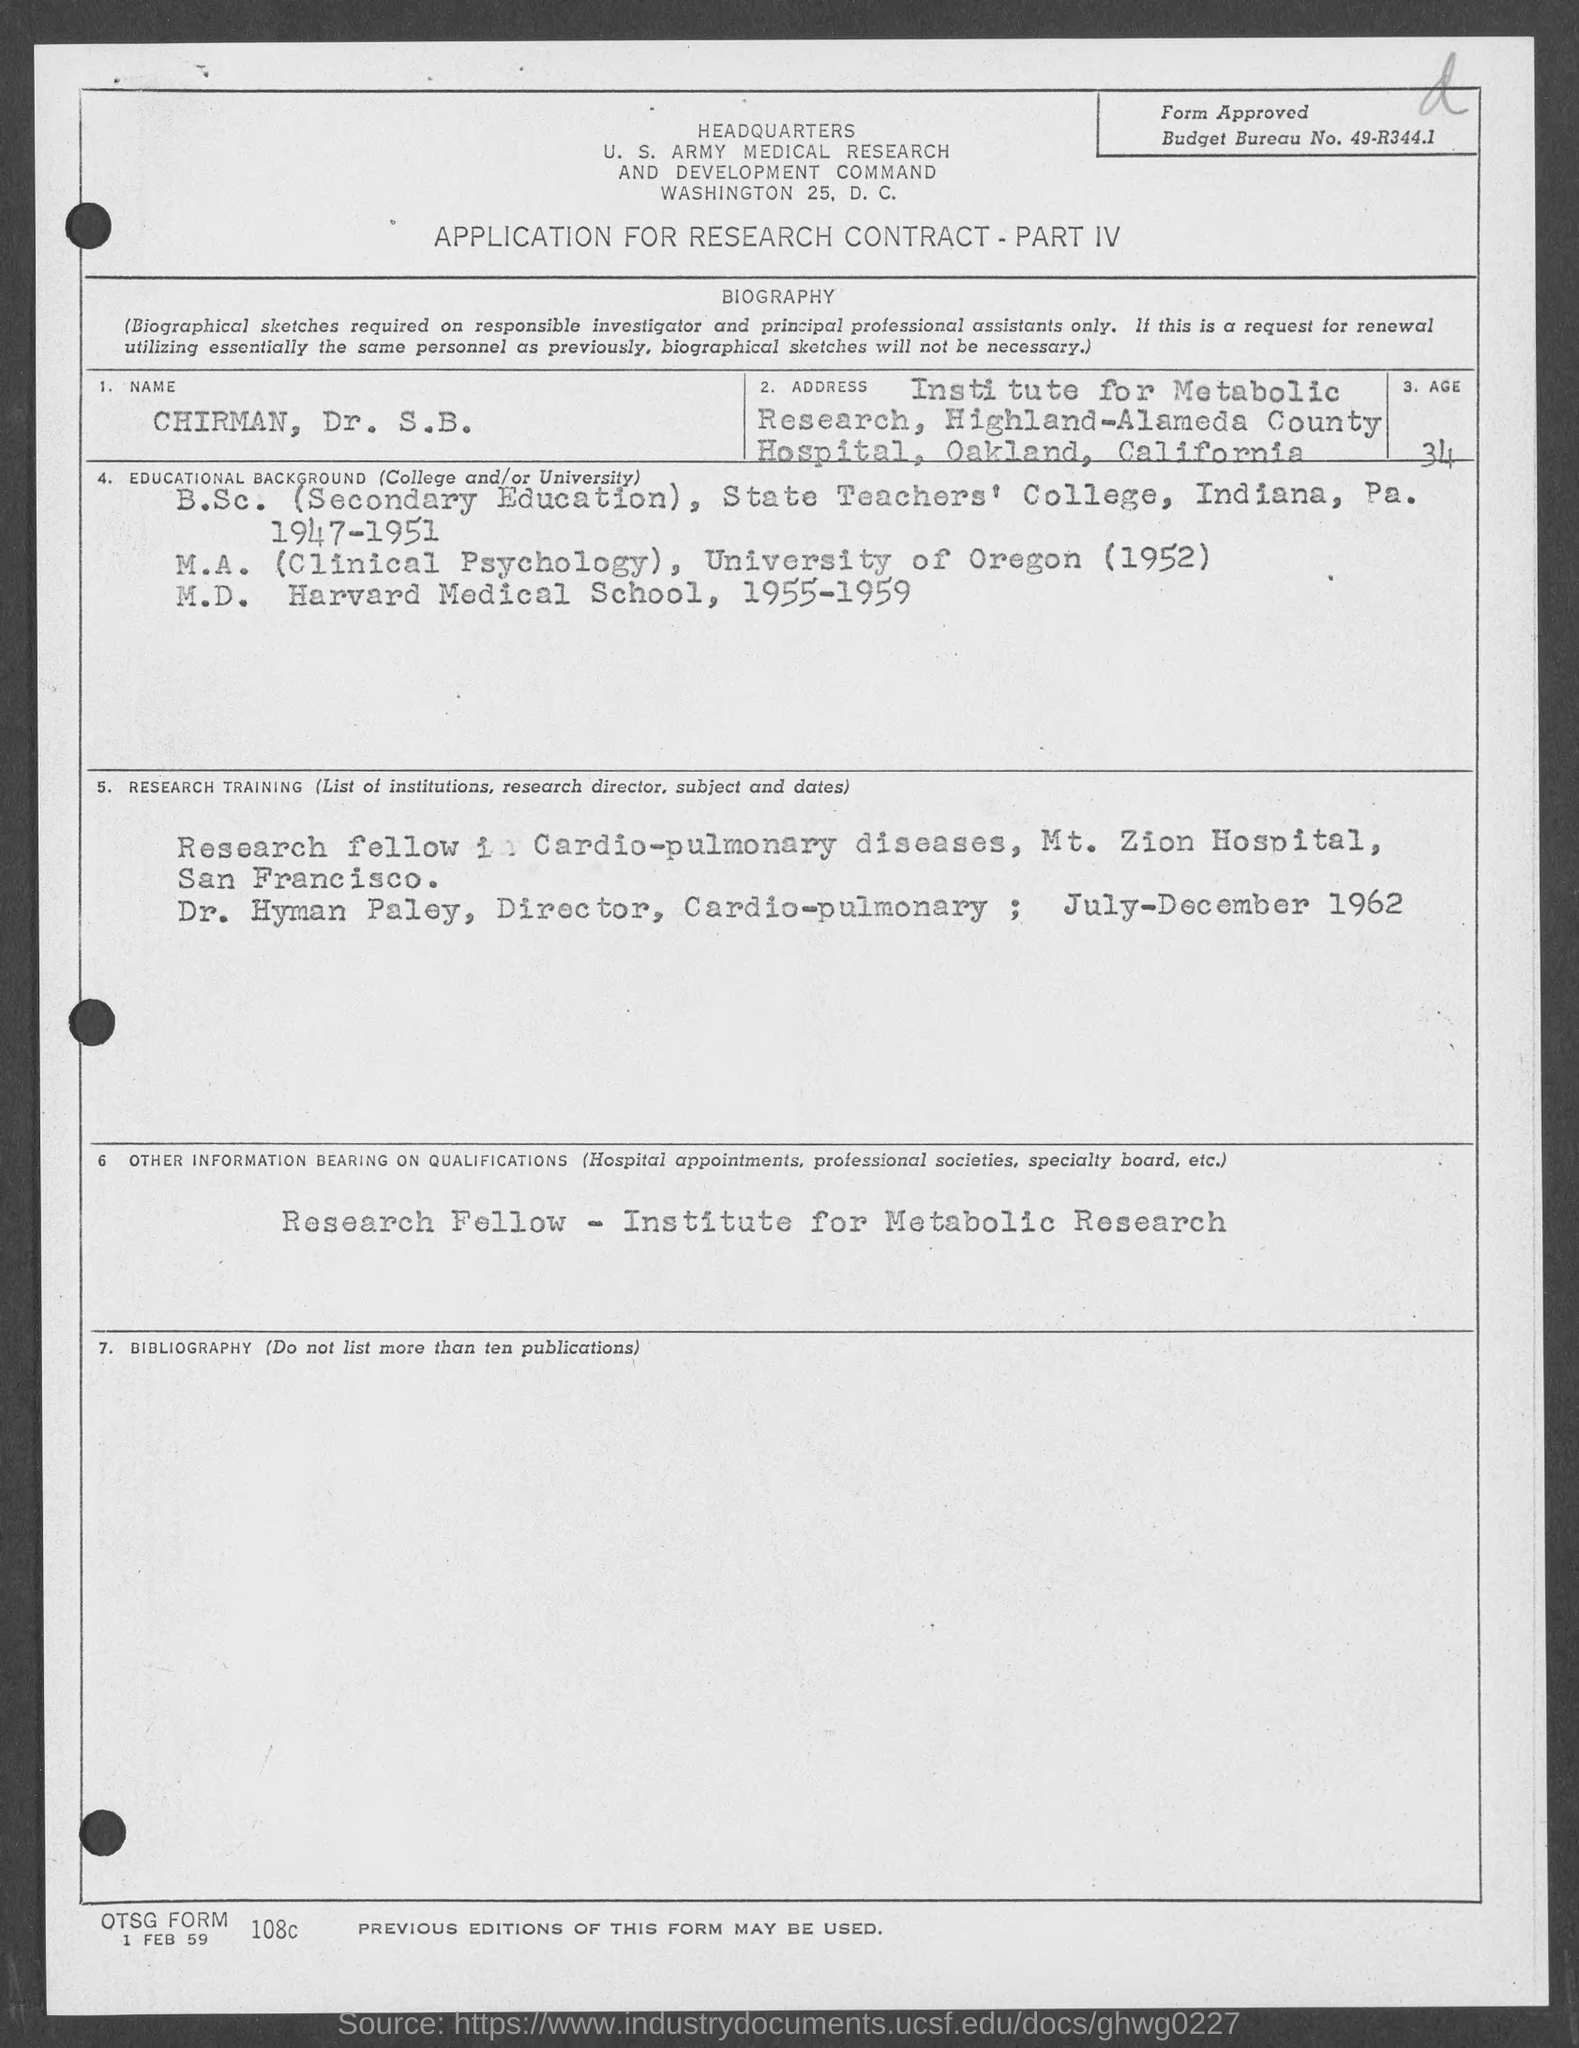What is the budget bureau no.?
Your answer should be compact. 49-R344.1. What is the name of the applicant in the form?
Your response must be concise. Chirman, Dr. S.B. What is the age of the applicant?
Your answer should be very brief. 34. In which year did applicant complete his m.a. ?
Provide a succinct answer. 1952. 